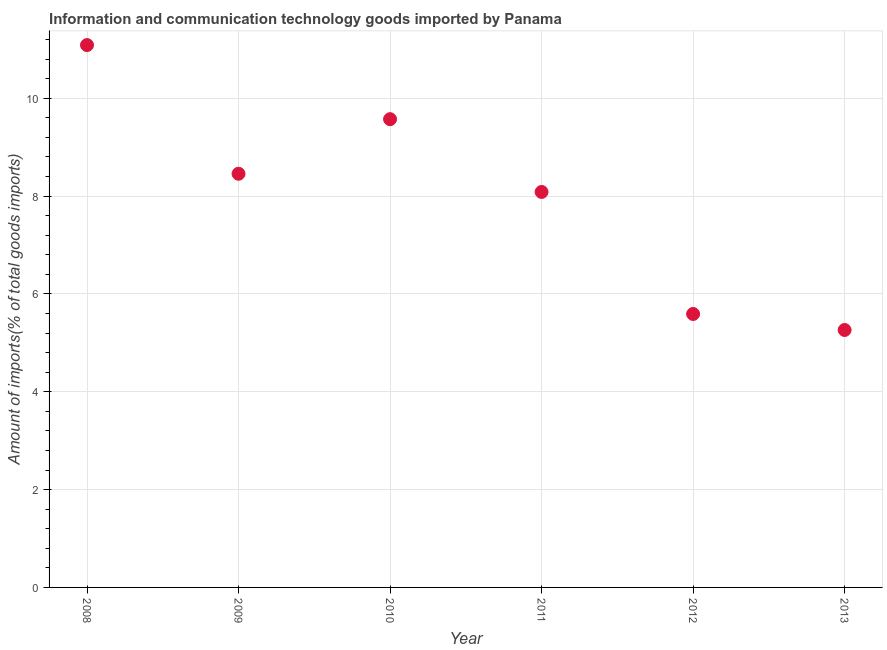What is the amount of ict goods imports in 2010?
Give a very brief answer. 9.57. Across all years, what is the maximum amount of ict goods imports?
Your answer should be compact. 11.09. Across all years, what is the minimum amount of ict goods imports?
Give a very brief answer. 5.26. What is the sum of the amount of ict goods imports?
Offer a terse response. 48.05. What is the difference between the amount of ict goods imports in 2012 and 2013?
Your response must be concise. 0.33. What is the average amount of ict goods imports per year?
Give a very brief answer. 8.01. What is the median amount of ict goods imports?
Keep it short and to the point. 8.27. In how many years, is the amount of ict goods imports greater than 10.4 %?
Offer a very short reply. 1. What is the ratio of the amount of ict goods imports in 2010 to that in 2013?
Your response must be concise. 1.82. What is the difference between the highest and the second highest amount of ict goods imports?
Provide a succinct answer. 1.51. Is the sum of the amount of ict goods imports in 2009 and 2013 greater than the maximum amount of ict goods imports across all years?
Provide a succinct answer. Yes. What is the difference between the highest and the lowest amount of ict goods imports?
Offer a very short reply. 5.82. Does the amount of ict goods imports monotonically increase over the years?
Provide a short and direct response. No. How many years are there in the graph?
Make the answer very short. 6. What is the difference between two consecutive major ticks on the Y-axis?
Make the answer very short. 2. Are the values on the major ticks of Y-axis written in scientific E-notation?
Give a very brief answer. No. Does the graph contain any zero values?
Offer a very short reply. No. Does the graph contain grids?
Your answer should be compact. Yes. What is the title of the graph?
Make the answer very short. Information and communication technology goods imported by Panama. What is the label or title of the Y-axis?
Provide a short and direct response. Amount of imports(% of total goods imports). What is the Amount of imports(% of total goods imports) in 2008?
Give a very brief answer. 11.09. What is the Amount of imports(% of total goods imports) in 2009?
Your answer should be compact. 8.46. What is the Amount of imports(% of total goods imports) in 2010?
Provide a short and direct response. 9.57. What is the Amount of imports(% of total goods imports) in 2011?
Provide a succinct answer. 8.08. What is the Amount of imports(% of total goods imports) in 2012?
Your answer should be very brief. 5.59. What is the Amount of imports(% of total goods imports) in 2013?
Ensure brevity in your answer.  5.26. What is the difference between the Amount of imports(% of total goods imports) in 2008 and 2009?
Provide a short and direct response. 2.63. What is the difference between the Amount of imports(% of total goods imports) in 2008 and 2010?
Keep it short and to the point. 1.51. What is the difference between the Amount of imports(% of total goods imports) in 2008 and 2011?
Keep it short and to the point. 3. What is the difference between the Amount of imports(% of total goods imports) in 2008 and 2012?
Your answer should be compact. 5.5. What is the difference between the Amount of imports(% of total goods imports) in 2008 and 2013?
Your response must be concise. 5.82. What is the difference between the Amount of imports(% of total goods imports) in 2009 and 2010?
Keep it short and to the point. -1.12. What is the difference between the Amount of imports(% of total goods imports) in 2009 and 2011?
Your answer should be very brief. 0.37. What is the difference between the Amount of imports(% of total goods imports) in 2009 and 2012?
Offer a terse response. 2.87. What is the difference between the Amount of imports(% of total goods imports) in 2009 and 2013?
Provide a succinct answer. 3.19. What is the difference between the Amount of imports(% of total goods imports) in 2010 and 2011?
Your answer should be very brief. 1.49. What is the difference between the Amount of imports(% of total goods imports) in 2010 and 2012?
Offer a terse response. 3.98. What is the difference between the Amount of imports(% of total goods imports) in 2010 and 2013?
Your answer should be compact. 4.31. What is the difference between the Amount of imports(% of total goods imports) in 2011 and 2012?
Your answer should be compact. 2.49. What is the difference between the Amount of imports(% of total goods imports) in 2011 and 2013?
Keep it short and to the point. 2.82. What is the difference between the Amount of imports(% of total goods imports) in 2012 and 2013?
Your answer should be compact. 0.33. What is the ratio of the Amount of imports(% of total goods imports) in 2008 to that in 2009?
Provide a succinct answer. 1.31. What is the ratio of the Amount of imports(% of total goods imports) in 2008 to that in 2010?
Make the answer very short. 1.16. What is the ratio of the Amount of imports(% of total goods imports) in 2008 to that in 2011?
Offer a terse response. 1.37. What is the ratio of the Amount of imports(% of total goods imports) in 2008 to that in 2012?
Offer a very short reply. 1.98. What is the ratio of the Amount of imports(% of total goods imports) in 2008 to that in 2013?
Your response must be concise. 2.11. What is the ratio of the Amount of imports(% of total goods imports) in 2009 to that in 2010?
Provide a short and direct response. 0.88. What is the ratio of the Amount of imports(% of total goods imports) in 2009 to that in 2011?
Give a very brief answer. 1.05. What is the ratio of the Amount of imports(% of total goods imports) in 2009 to that in 2012?
Make the answer very short. 1.51. What is the ratio of the Amount of imports(% of total goods imports) in 2009 to that in 2013?
Keep it short and to the point. 1.61. What is the ratio of the Amount of imports(% of total goods imports) in 2010 to that in 2011?
Your answer should be compact. 1.18. What is the ratio of the Amount of imports(% of total goods imports) in 2010 to that in 2012?
Your answer should be compact. 1.71. What is the ratio of the Amount of imports(% of total goods imports) in 2010 to that in 2013?
Offer a very short reply. 1.82. What is the ratio of the Amount of imports(% of total goods imports) in 2011 to that in 2012?
Provide a short and direct response. 1.45. What is the ratio of the Amount of imports(% of total goods imports) in 2011 to that in 2013?
Ensure brevity in your answer.  1.54. What is the ratio of the Amount of imports(% of total goods imports) in 2012 to that in 2013?
Offer a terse response. 1.06. 